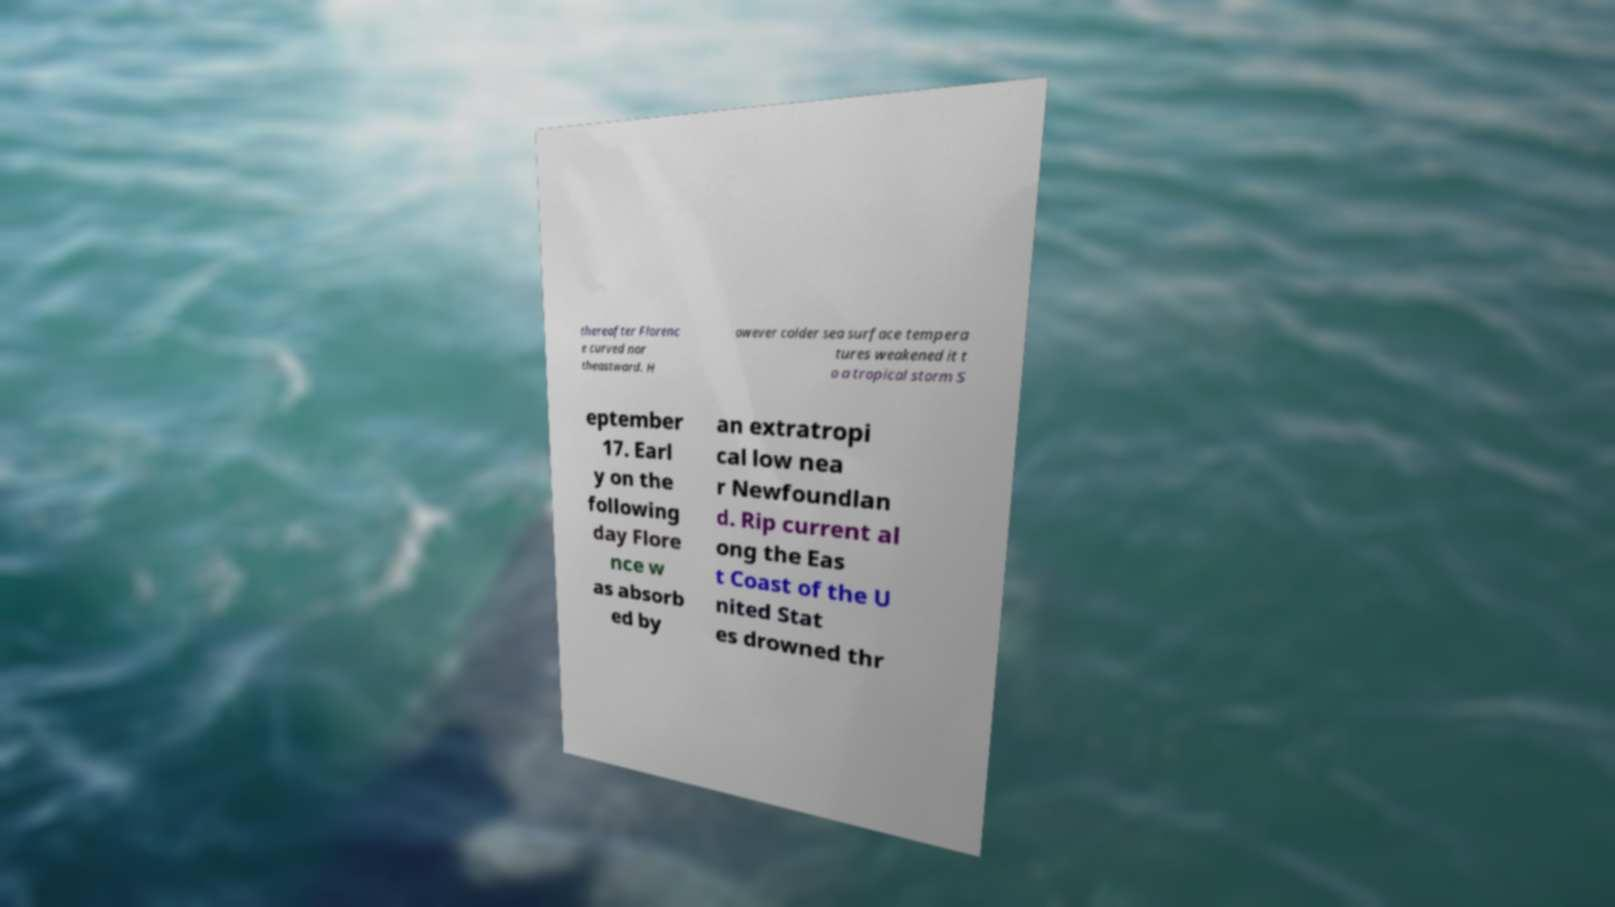Please read and relay the text visible in this image. What does it say? thereafter Florenc e curved nor theastward. H owever colder sea surface tempera tures weakened it t o a tropical storm S eptember 17. Earl y on the following day Flore nce w as absorb ed by an extratropi cal low nea r Newfoundlan d. Rip current al ong the Eas t Coast of the U nited Stat es drowned thr 